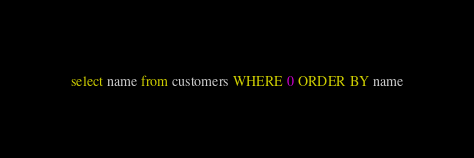<code> <loc_0><loc_0><loc_500><loc_500><_SQL_>select name from customers WHERE 0 ORDER BY name</code> 